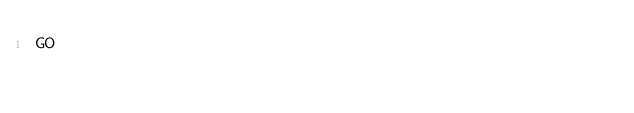<code> <loc_0><loc_0><loc_500><loc_500><_SQL_>GO
</code> 